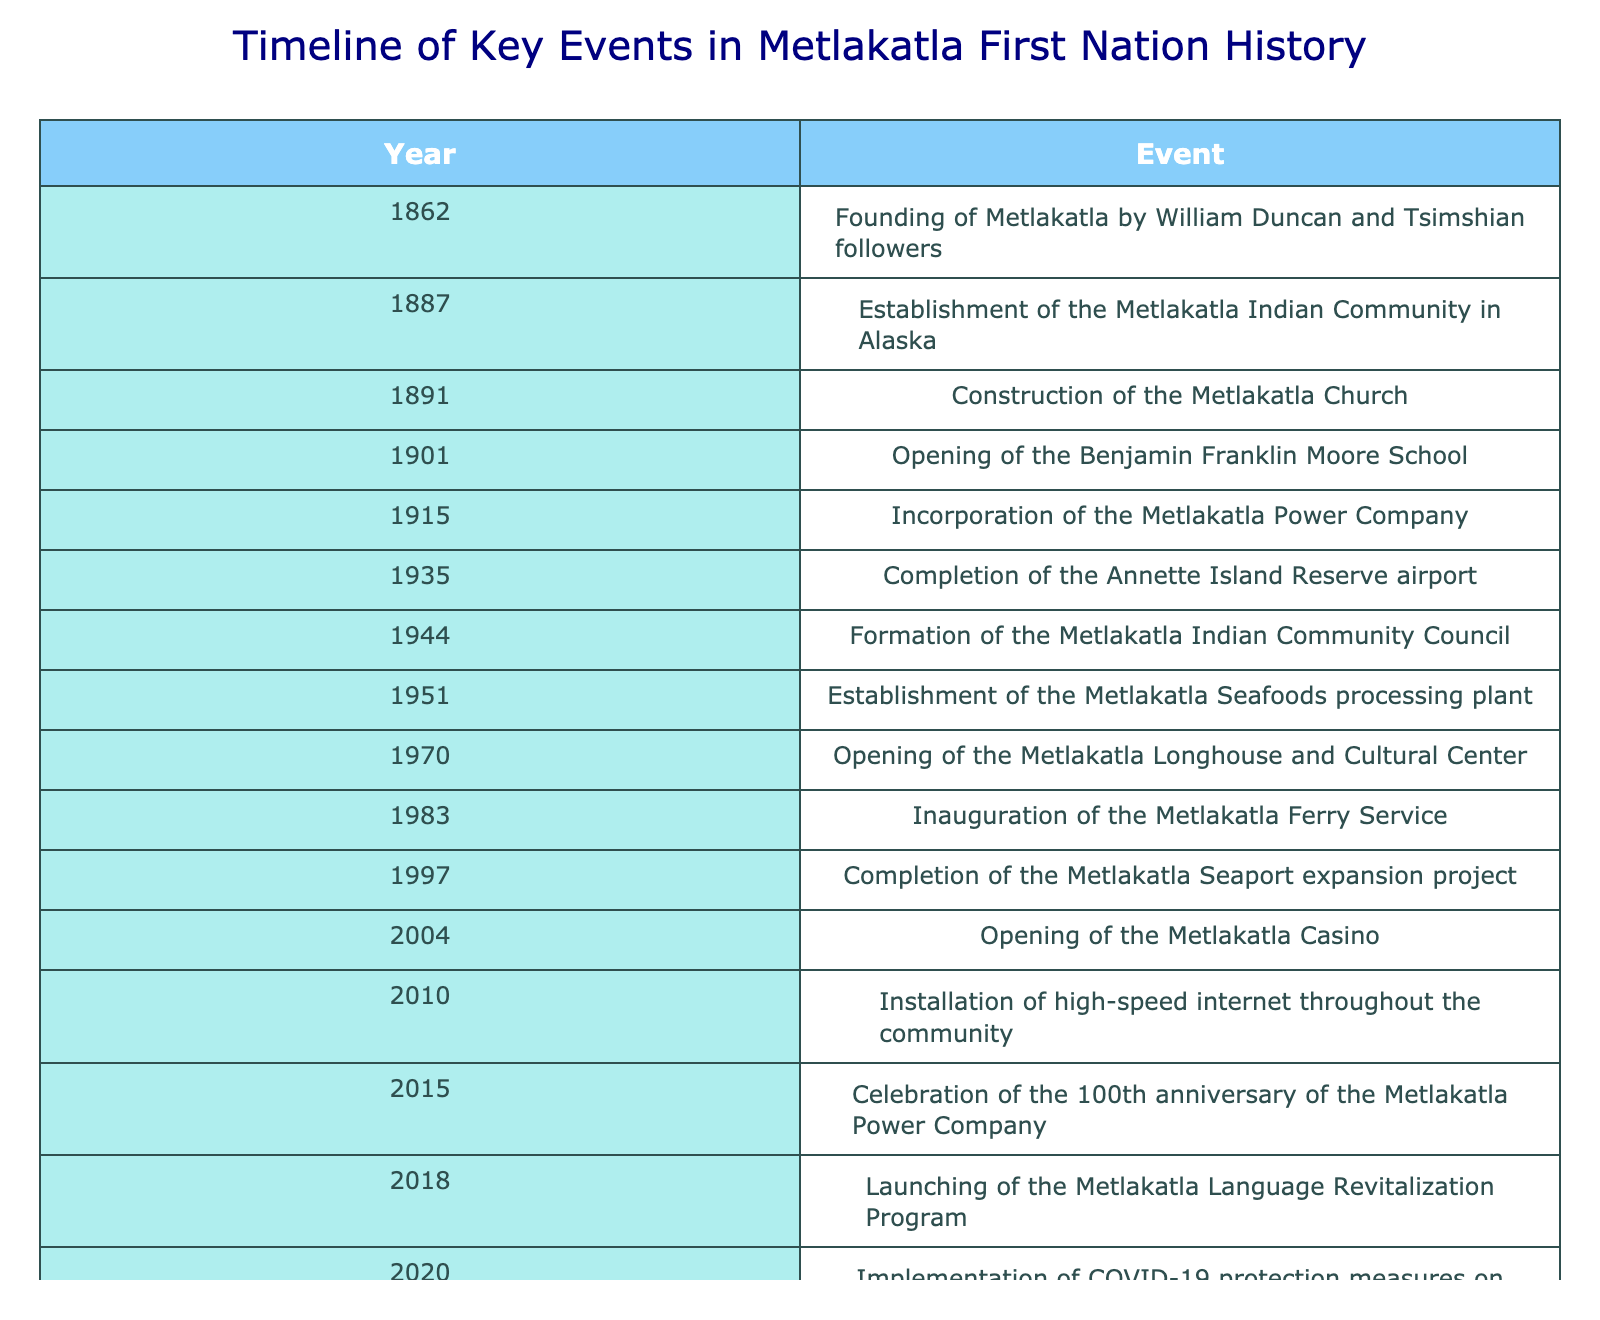What year was the Metlakatla Indian Community established in Alaska? The table indicates that the Metlakatla Indian Community was established in 1887. This is a direct retrieval from the table.
Answer: 1887 What is the earliest event in the timeline of key events for the Metlakatla First Nation? The earliest event listed in the table is the founding of Metlakatla by William Duncan and Tsimshian followers in 1862. This can be easily found by looking at the first row of the table.
Answer: 1862 How many years passed between the founding of Metlakatla and the opening of the Metlakatla Casino? The founding of Metlakatla occurred in 1862 and the Metlakatla Casino opened in 2004. To find the difference: 2004 - 1862 = 142 years. This involves subtracting the years from one another to find the time span.
Answer: 142 Was the Metlakatla Seafoods processing plant established before or after the Metlakatla Longhouse and Cultural Center? The Metlakatla Seafoods processing plant was established in 1951 and the Metlakatla Longhouse and Cultural Center opened in 1970. Since 1951 is earlier than 1970, the statement is true. This involves comparing the years of both events.
Answer: After How many events occurred between the completion of the Annette Island Reserve airport and the opening of the Metlakatla Casino? The Annette Island Reserve airport was completed in 1935, and the Metlakatla Casino opened in 2004. The events between these years are: Formation of the Metlakatla Indian Community Council (1944), Establishment of the Metlakatla Seafoods processing plant (1951), Opening of the Metlakatla Longhouse and Cultural Center (1970), Inauguration of the Metlakatla Ferry Service (1983), Completion of the Metlakatla Seaport expansion project (1997), and Installation of high-speed internet throughout the community (2010). This totals six events. This involves counting the relevant entries in the timeline that fall between the two years.
Answer: 6 What key development took place in 2015 in Metlakatla history? According to the table, in 2015, celebrations were held for the 100th anniversary of the Metlakatla Power Company. This can be retrieved directly from the corresponding row in the table.
Answer: Celebration of the 100th anniversary of the Metlakatla Power Company 